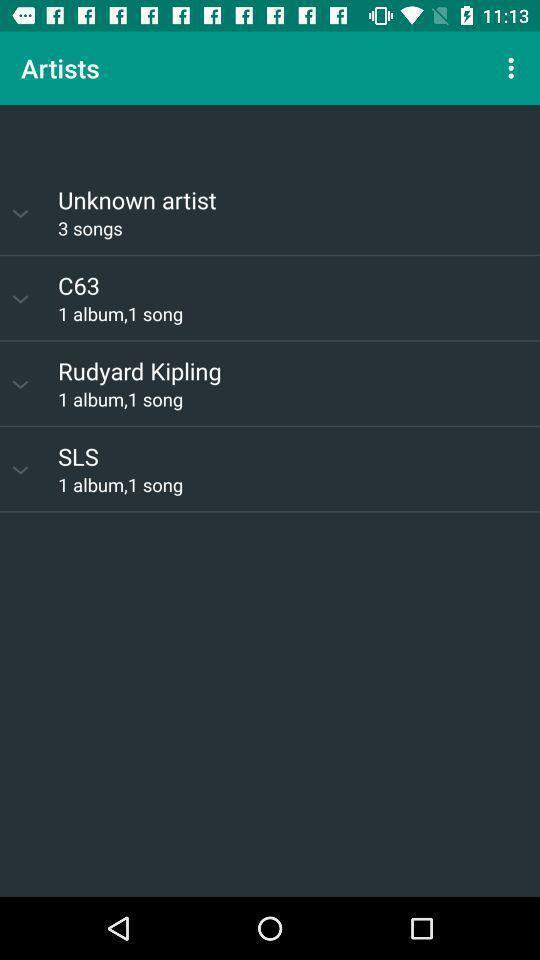Summarize the information in this screenshot. Screen displaying the artists page in music app. 